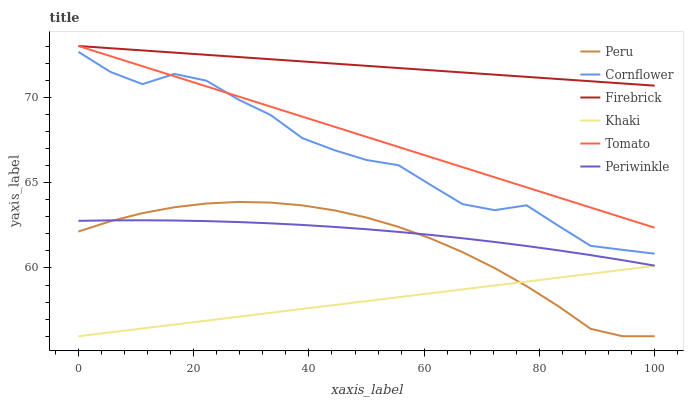Does Khaki have the minimum area under the curve?
Answer yes or no. Yes. Does Firebrick have the maximum area under the curve?
Answer yes or no. Yes. Does Cornflower have the minimum area under the curve?
Answer yes or no. No. Does Cornflower have the maximum area under the curve?
Answer yes or no. No. Is Khaki the smoothest?
Answer yes or no. Yes. Is Cornflower the roughest?
Answer yes or no. Yes. Is Cornflower the smoothest?
Answer yes or no. No. Is Khaki the roughest?
Answer yes or no. No. Does Khaki have the lowest value?
Answer yes or no. Yes. Does Cornflower have the lowest value?
Answer yes or no. No. Does Firebrick have the highest value?
Answer yes or no. Yes. Does Cornflower have the highest value?
Answer yes or no. No. Is Peru less than Tomato?
Answer yes or no. Yes. Is Tomato greater than Khaki?
Answer yes or no. Yes. Does Tomato intersect Firebrick?
Answer yes or no. Yes. Is Tomato less than Firebrick?
Answer yes or no. No. Is Tomato greater than Firebrick?
Answer yes or no. No. Does Peru intersect Tomato?
Answer yes or no. No. 